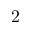Convert formula to latex. <formula><loc_0><loc_0><loc_500><loc_500>2</formula> 